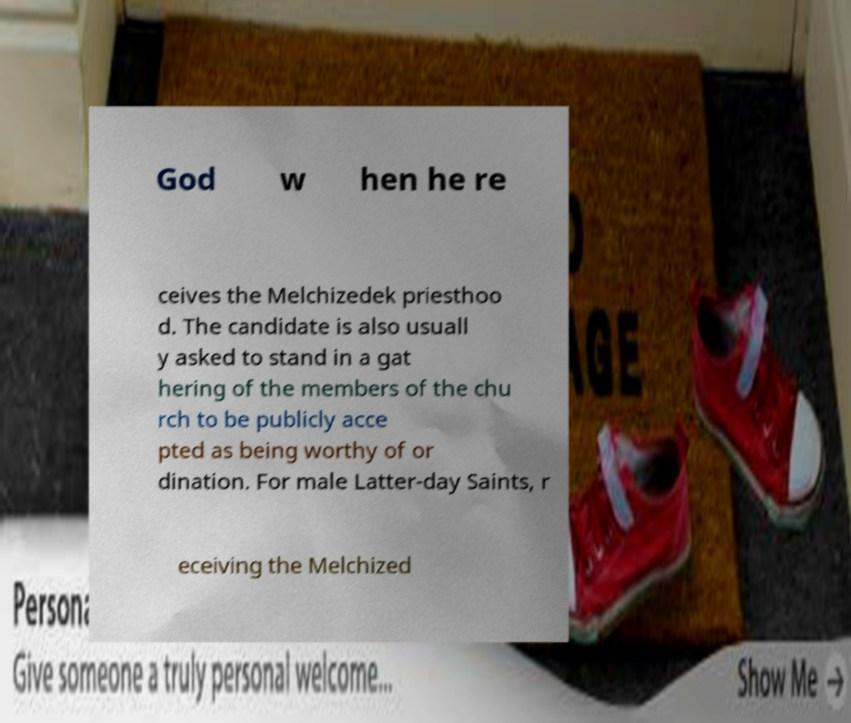What messages or text are displayed in this image? I need them in a readable, typed format. God w hen he re ceives the Melchizedek priesthoo d. The candidate is also usuall y asked to stand in a gat hering of the members of the chu rch to be publicly acce pted as being worthy of or dination. For male Latter-day Saints, r eceiving the Melchized 